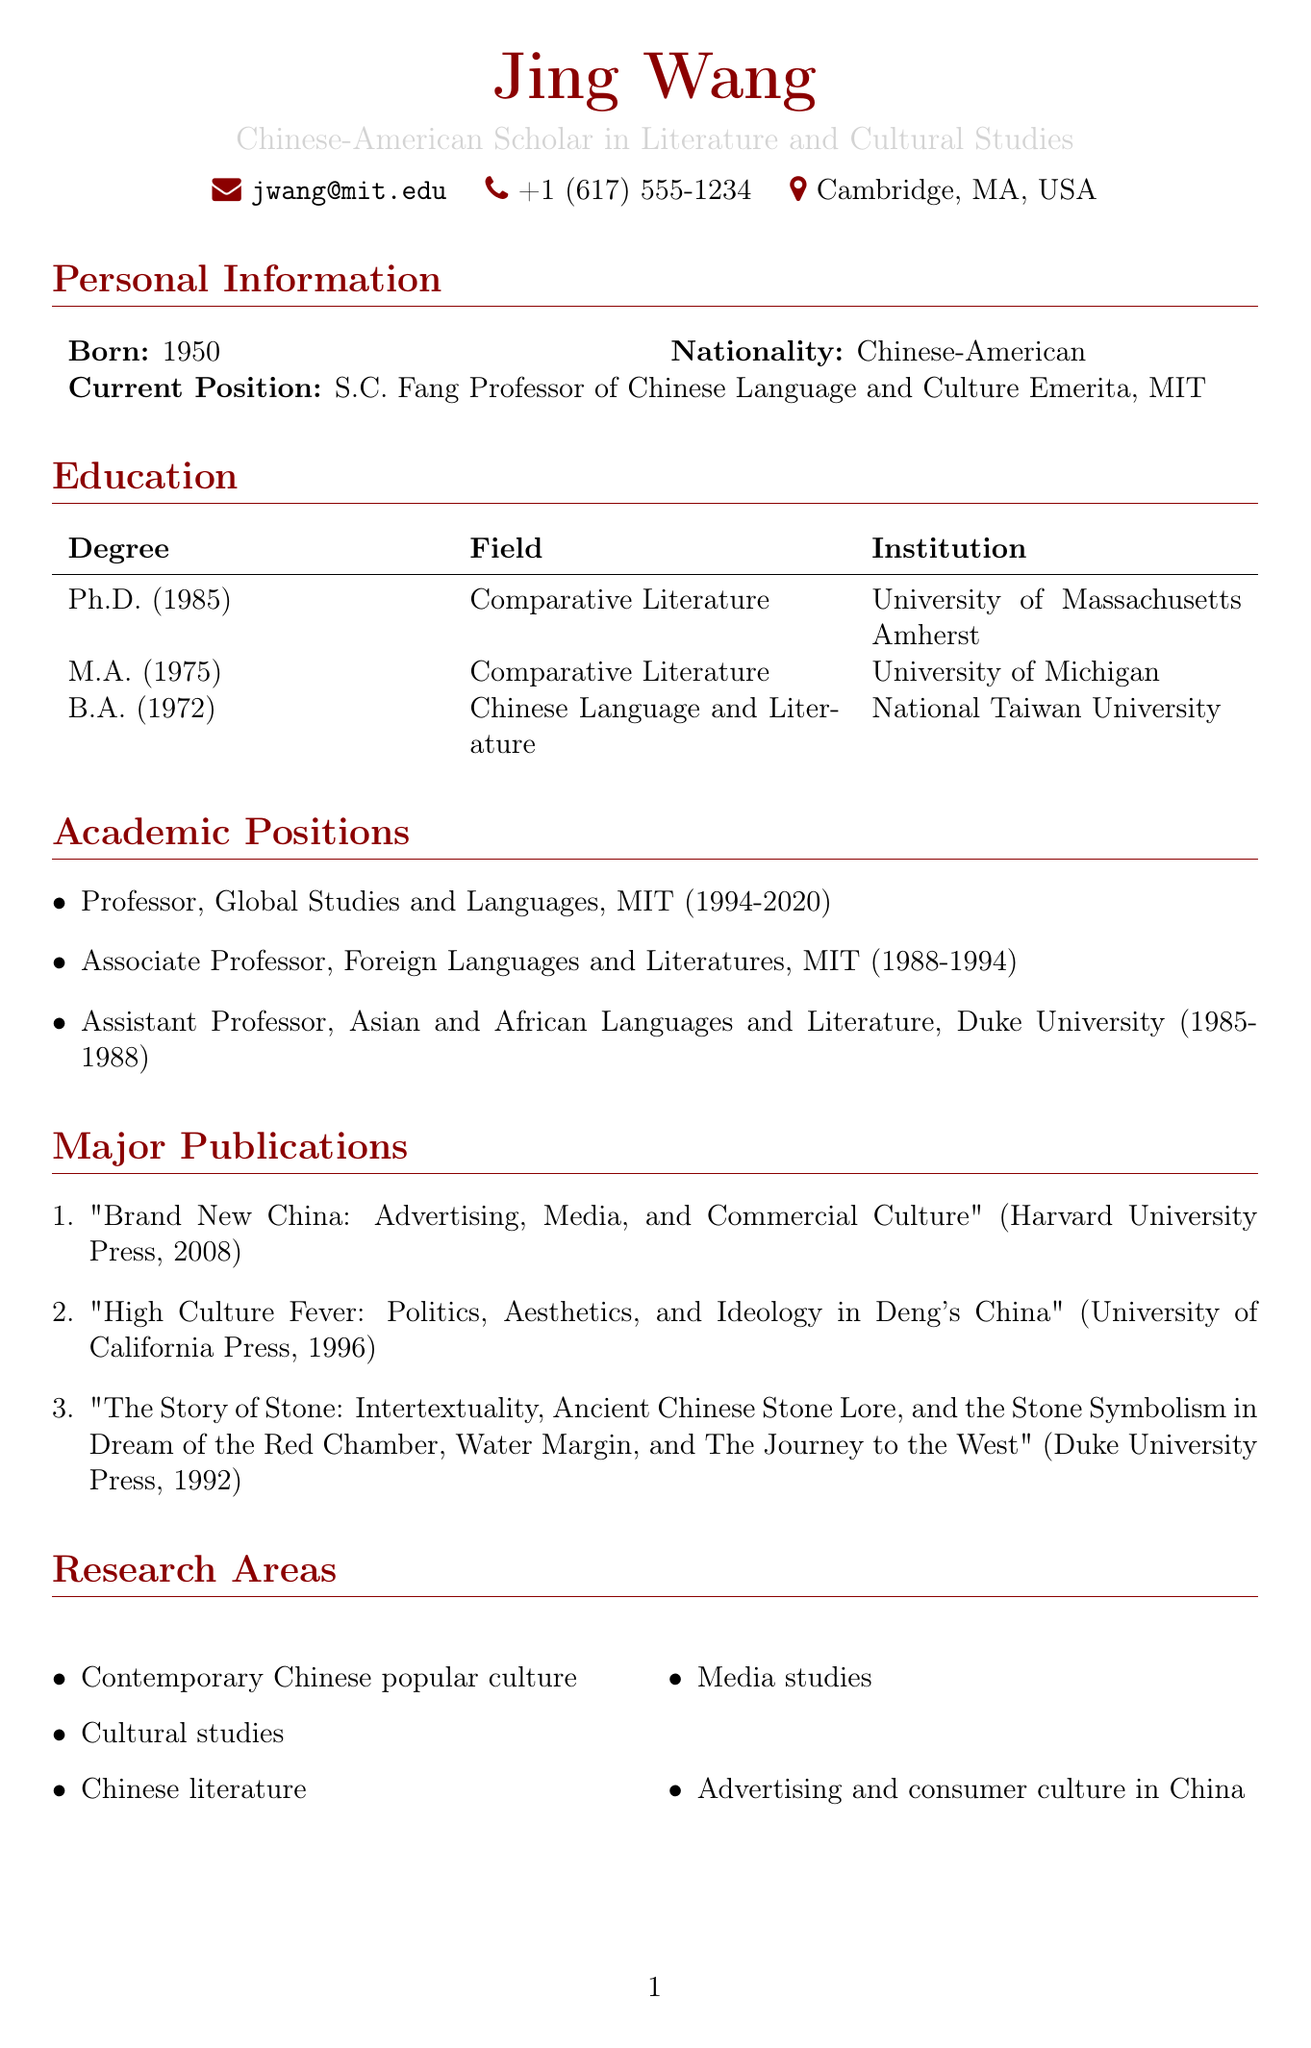What is Jing Wang's birth year? Jing Wang's birth year is mentioned in the personal information section of the document.
Answer: 1950 What position does Jing Wang currently hold? The document states her current position as mentioned in the personal information section.
Answer: S.C. Fang Professor of Chinese Language and Culture Emerita, Massachusetts Institute of Technology Which institution awarded Jing Wang her Ph.D.? The institution where Jing Wang obtained her Ph.D. is listed in the education section of the document.
Answer: University of Massachusetts Amherst How many awards has Jing Wang received? The document lists two awards under the awards section, indicating the count of awards received.
Answer: 2 What is one of Jing Wang's research areas? The research areas are listed in a bullet format in the document, revealing multiple areas of study.
Answer: Contemporary Chinese popular culture Which publication did Jing Wang receive the Levenson Prize for? The specific work for which the Levenson Prize was awarded is detailed in the awards section of the document.
Answer: The Story of Stone What type of fellowship did Jing Wang receive in 2000? The document specifies the type of recognition she received in 2000 under the awards section.
Answer: Guggenheim Fellowship Name one professional membership of Jing Wang. The document includes a list of professional memberships in a bullet format, showcasing her affiliations.
Answer: Association for Asian Studies What is the emphasis of Jing Wang's impact on Chinese studies? The impact section of the document outlines key contributions by Jing Wang to the field of Chinese studies.
Answer: Integration of cultural studies approaches in Chinese literary studies 